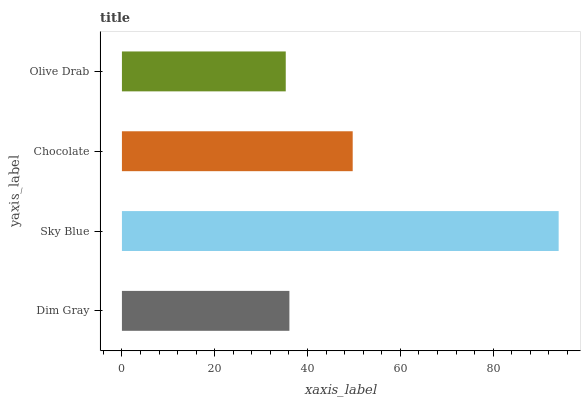Is Olive Drab the minimum?
Answer yes or no. Yes. Is Sky Blue the maximum?
Answer yes or no. Yes. Is Chocolate the minimum?
Answer yes or no. No. Is Chocolate the maximum?
Answer yes or no. No. Is Sky Blue greater than Chocolate?
Answer yes or no. Yes. Is Chocolate less than Sky Blue?
Answer yes or no. Yes. Is Chocolate greater than Sky Blue?
Answer yes or no. No. Is Sky Blue less than Chocolate?
Answer yes or no. No. Is Chocolate the high median?
Answer yes or no. Yes. Is Dim Gray the low median?
Answer yes or no. Yes. Is Olive Drab the high median?
Answer yes or no. No. Is Sky Blue the low median?
Answer yes or no. No. 